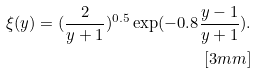<formula> <loc_0><loc_0><loc_500><loc_500>\xi ( y ) = ( \frac { 2 } { y + 1 } ) ^ { 0 . 5 } \exp ( - 0 . 8 \frac { y - 1 } { y + 1 } ) . \\ [ 3 m m ]</formula> 